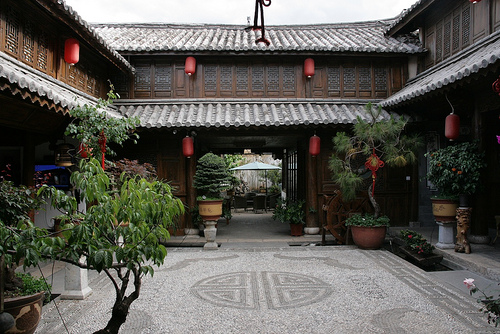<image>
Is the building behind the tree? Yes. From this viewpoint, the building is positioned behind the tree, with the tree partially or fully occluding the building. 